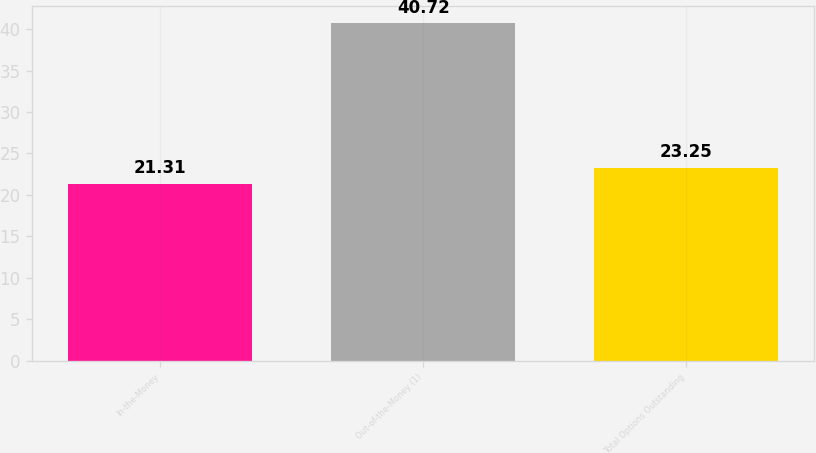<chart> <loc_0><loc_0><loc_500><loc_500><bar_chart><fcel>In-the-Money<fcel>Out-of-the-Money (1)<fcel>Total Options Outstanding<nl><fcel>21.31<fcel>40.72<fcel>23.25<nl></chart> 